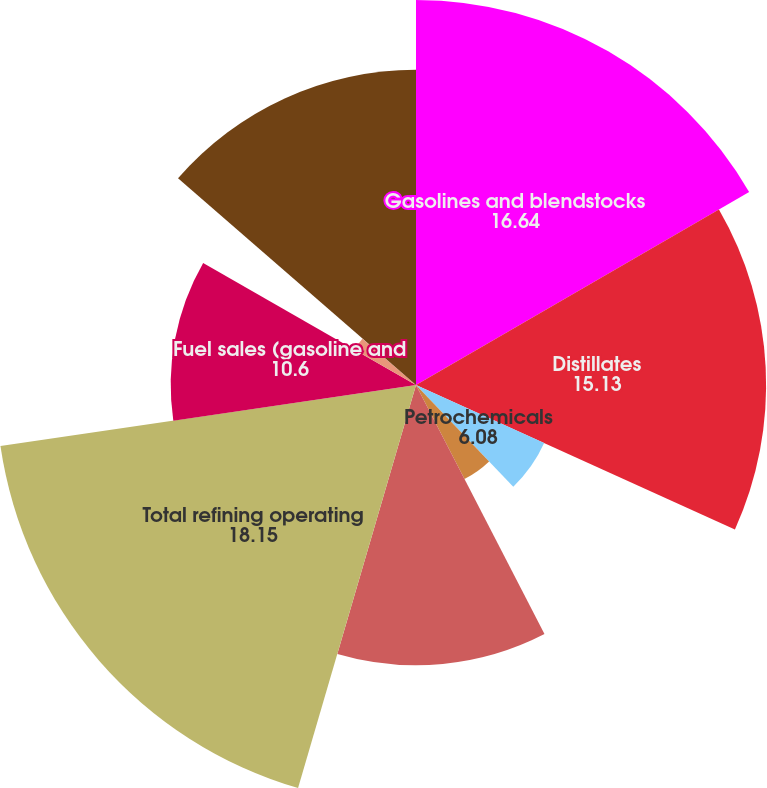Convert chart to OTSL. <chart><loc_0><loc_0><loc_500><loc_500><pie_chart><fcel>Gasolines and blendstocks<fcel>Distillates<fcel>Petrochemicals<fcel>Lubes and asphalts<fcel>Other product revenues<fcel>Total refining operating<fcel>Fuel sales (gasoline and<fcel>Merchandise sales and other<fcel>Home heating oil<fcel>Total retail operating<nl><fcel>16.64%<fcel>15.13%<fcel>6.08%<fcel>4.57%<fcel>12.11%<fcel>18.15%<fcel>10.6%<fcel>3.06%<fcel>0.04%<fcel>13.62%<nl></chart> 